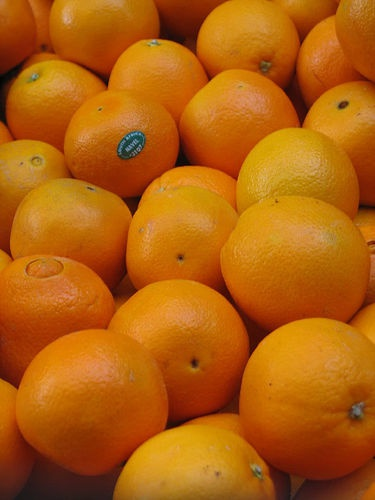Describe the objects in this image and their specific colors. I can see orange in orange, red, and maroon tones, orange in orange, red, and maroon tones, orange in orange, red, and maroon tones, orange in orange, red, and brown tones, and orange in orange, red, and maroon tones in this image. 